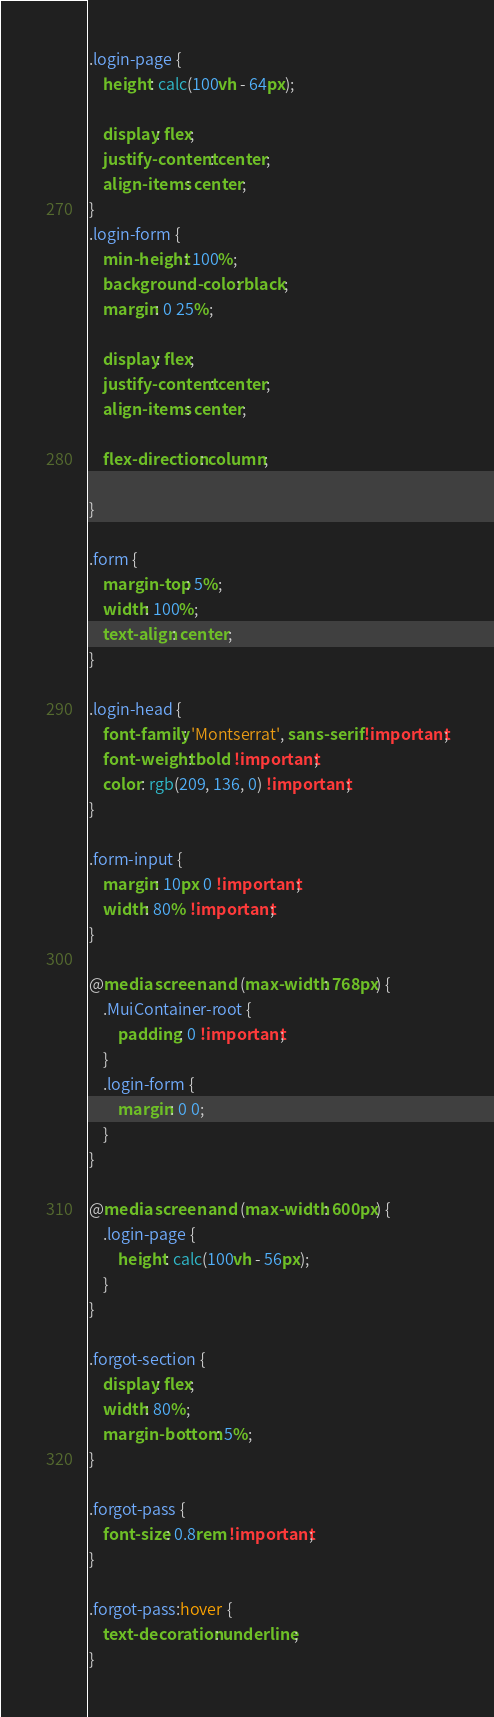Convert code to text. <code><loc_0><loc_0><loc_500><loc_500><_CSS_>.login-page {
	height: calc(100vh - 64px);
	
	display: flex;
	justify-content: center;
	align-items: center;
}
.login-form {
	min-height: 100%;
	background-color: black;
	margin: 0 25%;

	display: flex;
	justify-content: center;
	align-items: center;

	flex-direction: column;
	
}

.form {
	margin-top: 5%;
	width: 100%;
	text-align: center;
}

.login-head {
	font-family: 'Montserrat', sans-serif !important;
	font-weight: bold !important;
	color: rgb(209, 136, 0) !important;
}

.form-input {
	margin: 10px 0 !important;
	width: 80% !important;
}

@media screen and (max-width: 768px) {
	.MuiContainer-root {
		padding: 0 !important;
	}
	.login-form {
		margin: 0 0;
	}
}

@media screen and (max-width: 600px) {
	.login-page {
		height: calc(100vh - 56px);
	}
}

.forgot-section {
	display: flex;
	width: 80%;
	margin-bottom: 5%;
}

.forgot-pass {
	font-size: 0.8rem !important;
}

.forgot-pass:hover {
	text-decoration: underline;
}
</code> 